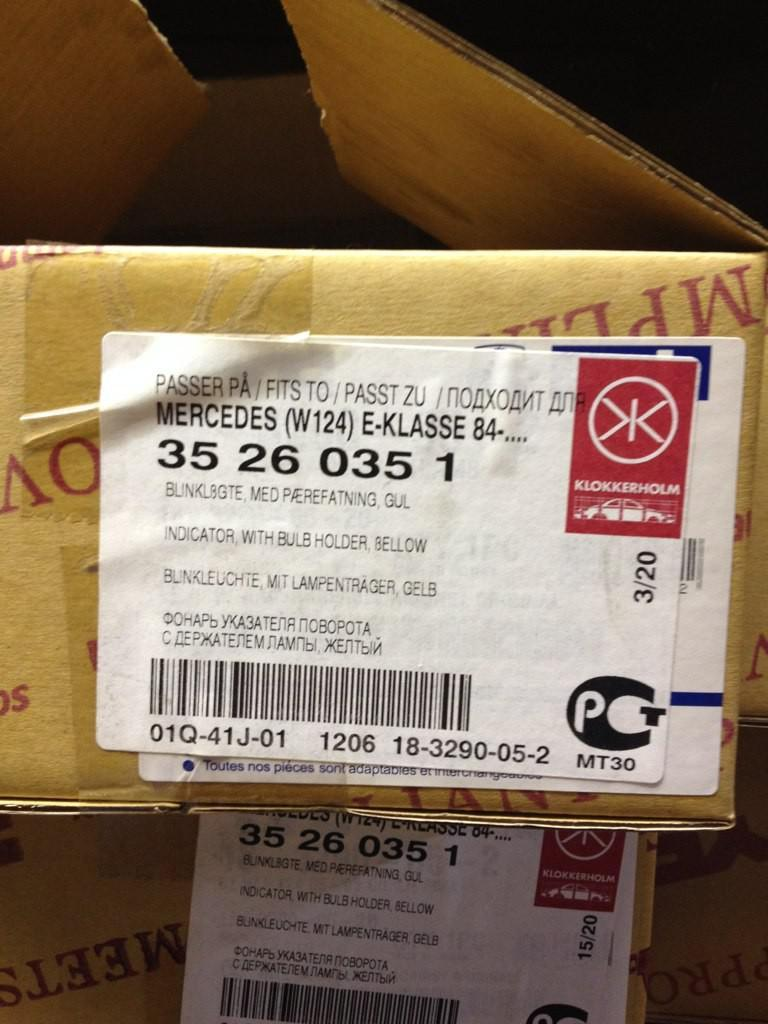<image>
Present a compact description of the photo's key features. a cardboard box with a label from  mercedes address to bunklbgte medpaerefatning 